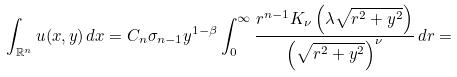Convert formula to latex. <formula><loc_0><loc_0><loc_500><loc_500>\int _ { \mathbb { R } ^ { n } } u ( x , y ) \, d x = C _ { n } \sigma _ { n - 1 } y ^ { 1 - \beta } \int _ { 0 } ^ { \infty } \frac { r ^ { n - 1 } K _ { \nu } \left ( \lambda \sqrt { r ^ { 2 } + y ^ { 2 } } \right ) } { \left ( \sqrt { r ^ { 2 } + y ^ { 2 } } \right ) ^ { \nu } } \, d r =</formula> 